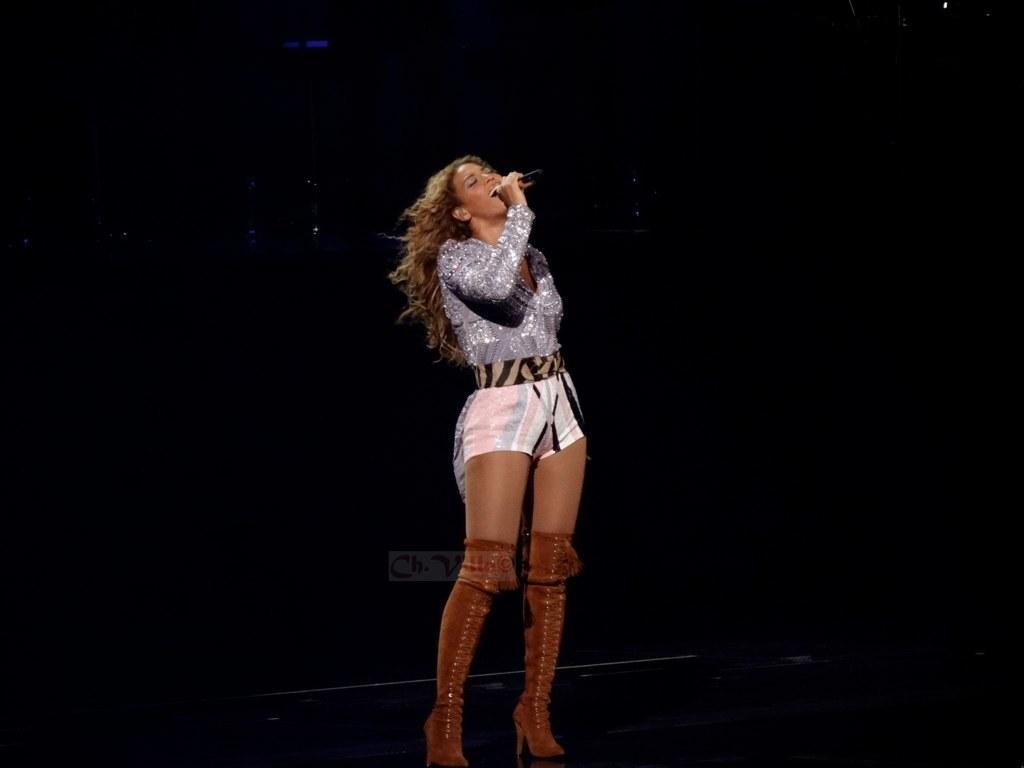Can you describe this image briefly? In this image there is a woman standing. She is holding a microphone in her hand. It seems like she's singing. The background is dark. 